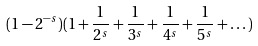<formula> <loc_0><loc_0><loc_500><loc_500>( 1 - 2 ^ { - s } ) ( 1 + \frac { 1 } { 2 ^ { s } } + \frac { 1 } { 3 ^ { s } } + \frac { 1 } { 4 ^ { s } } + \frac { 1 } { 5 ^ { s } } + \dots )</formula> 